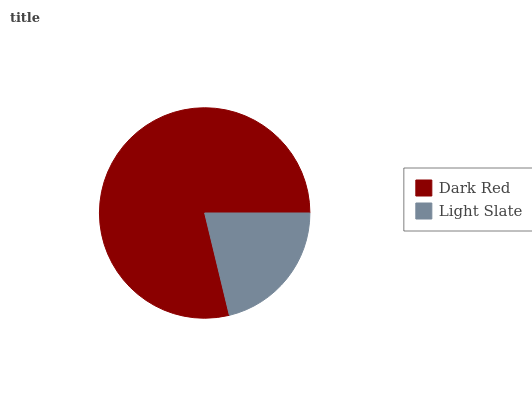Is Light Slate the minimum?
Answer yes or no. Yes. Is Dark Red the maximum?
Answer yes or no. Yes. Is Light Slate the maximum?
Answer yes or no. No. Is Dark Red greater than Light Slate?
Answer yes or no. Yes. Is Light Slate less than Dark Red?
Answer yes or no. Yes. Is Light Slate greater than Dark Red?
Answer yes or no. No. Is Dark Red less than Light Slate?
Answer yes or no. No. Is Dark Red the high median?
Answer yes or no. Yes. Is Light Slate the low median?
Answer yes or no. Yes. Is Light Slate the high median?
Answer yes or no. No. Is Dark Red the low median?
Answer yes or no. No. 